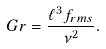<formula> <loc_0><loc_0><loc_500><loc_500>G r = \frac { \ell ^ { 3 } f _ { r m s } } { \nu ^ { 2 } } .</formula> 